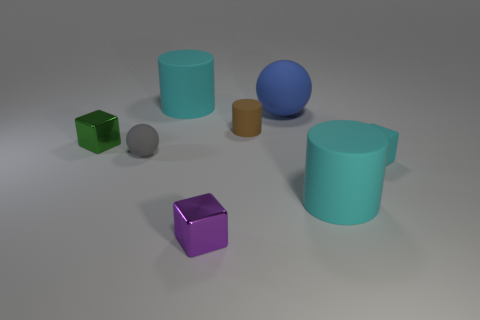Subtract all small cylinders. How many cylinders are left? 2 Subtract all gray spheres. How many spheres are left? 1 Add 1 large cyan rubber cylinders. How many objects exist? 9 Subtract 1 cylinders. How many cylinders are left? 2 Add 7 tiny gray rubber things. How many tiny gray rubber things are left? 8 Add 8 rubber cubes. How many rubber cubes exist? 9 Subtract 0 purple cylinders. How many objects are left? 8 Subtract all cubes. How many objects are left? 5 Subtract all purple cylinders. Subtract all brown spheres. How many cylinders are left? 3 Subtract all blue cylinders. How many blue spheres are left? 1 